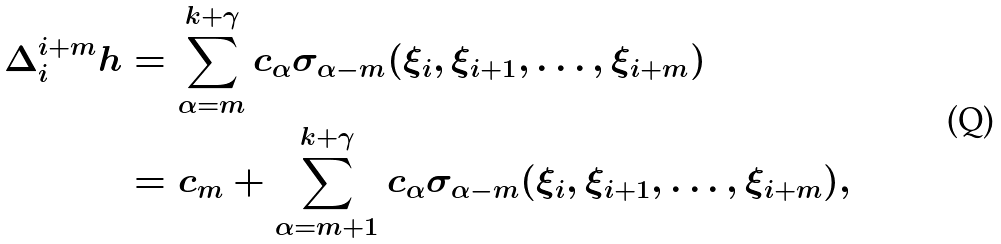Convert formula to latex. <formula><loc_0><loc_0><loc_500><loc_500>\Delta _ { i } ^ { i + m } h & = \sum _ { \alpha = m } ^ { k + \gamma } c _ { \alpha } \sigma _ { \alpha - m } ( \xi _ { i } , \xi _ { i + 1 } , \dots , \xi _ { i + m } ) \\ & = c _ { m } + \sum _ { \alpha = m + 1 } ^ { k + \gamma } c _ { \alpha } \sigma _ { \alpha - m } ( \xi _ { i } , \xi _ { i + 1 } , \dots , \xi _ { i + m } ) ,</formula> 